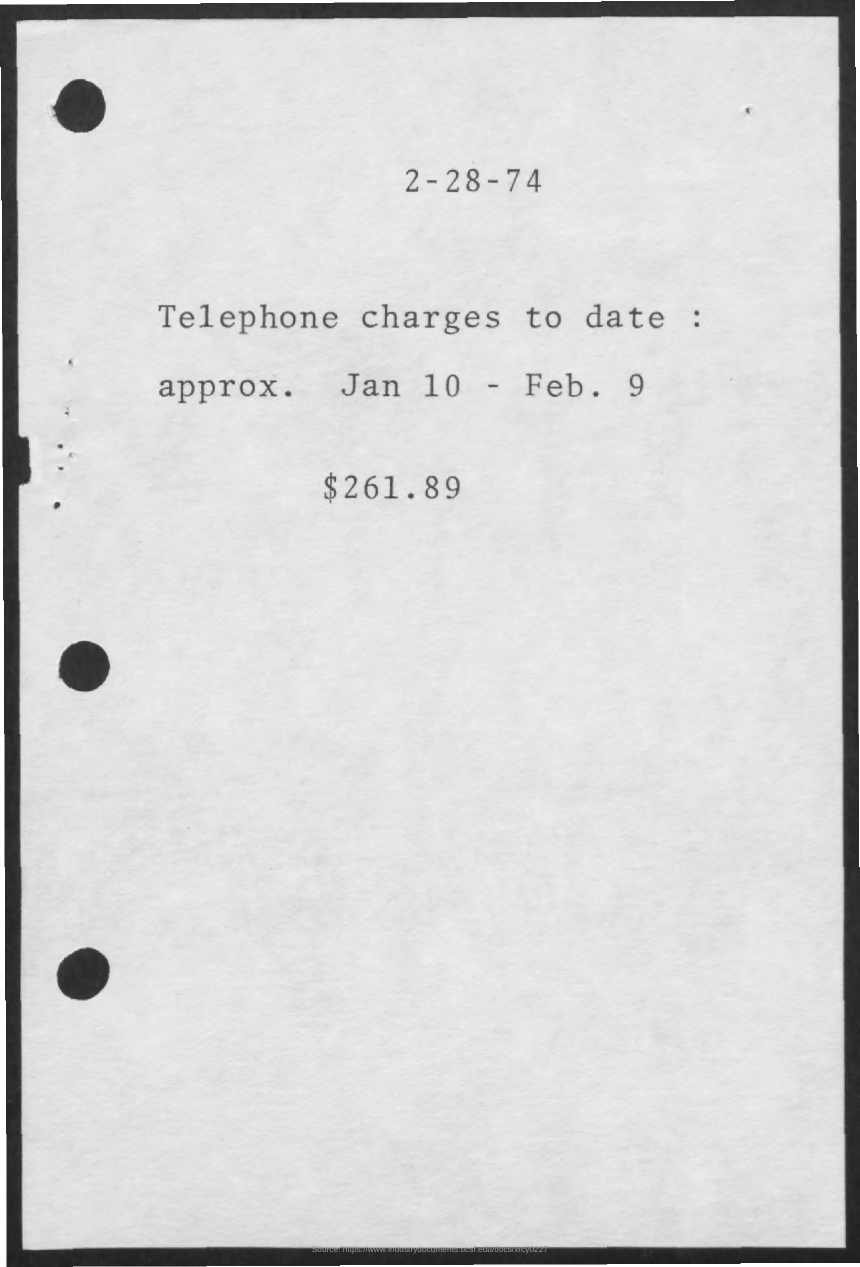What is date of document?
Make the answer very short. 2-28-74. What is the document about?
Offer a very short reply. Telephone charges. What is total telephone charges?
Offer a terse response. $261.89. 